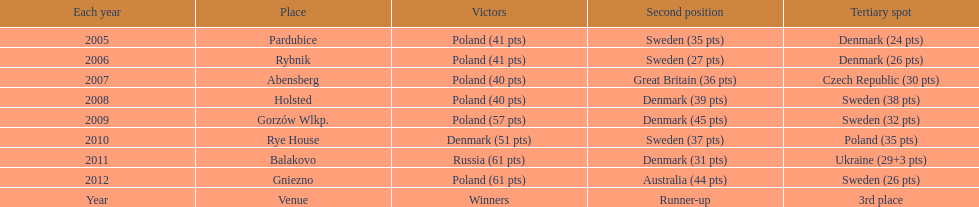Which team has the most third place wins in the speedway junior world championship between 2005 and 2012? Sweden. Can you give me this table as a dict? {'header': ['Each year', 'Place', 'Victors', 'Second position', 'Tertiary spot'], 'rows': [['2005', 'Pardubice', 'Poland (41 pts)', 'Sweden (35 pts)', 'Denmark (24 pts)'], ['2006', 'Rybnik', 'Poland (41 pts)', 'Sweden (27 pts)', 'Denmark (26 pts)'], ['2007', 'Abensberg', 'Poland (40 pts)', 'Great Britain (36 pts)', 'Czech Republic (30 pts)'], ['2008', 'Holsted', 'Poland (40 pts)', 'Denmark (39 pts)', 'Sweden (38 pts)'], ['2009', 'Gorzów Wlkp.', 'Poland (57 pts)', 'Denmark (45 pts)', 'Sweden (32 pts)'], ['2010', 'Rye House', 'Denmark (51 pts)', 'Sweden (37 pts)', 'Poland (35 pts)'], ['2011', 'Balakovo', 'Russia (61 pts)', 'Denmark (31 pts)', 'Ukraine (29+3 pts)'], ['2012', 'Gniezno', 'Poland (61 pts)', 'Australia (44 pts)', 'Sweden (26 pts)'], ['Year', 'Venue', 'Winners', 'Runner-up', '3rd place']]} 